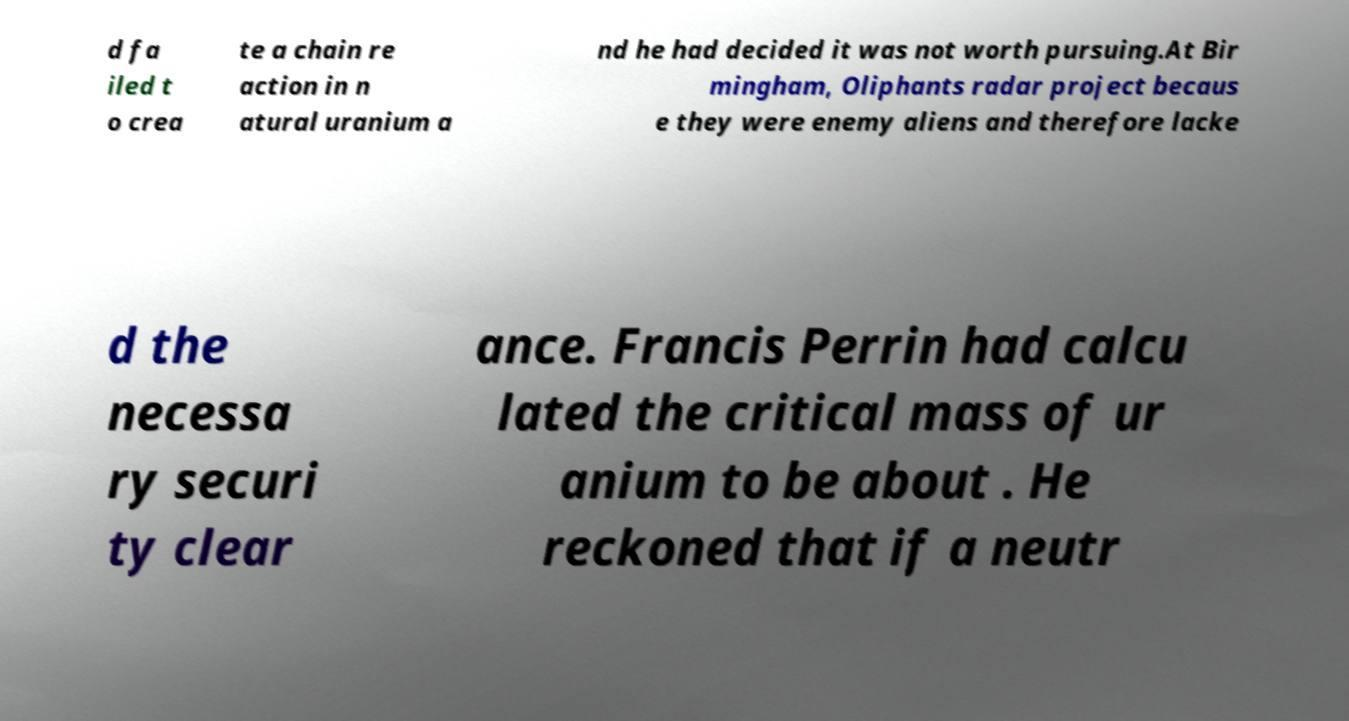Can you accurately transcribe the text from the provided image for me? d fa iled t o crea te a chain re action in n atural uranium a nd he had decided it was not worth pursuing.At Bir mingham, Oliphants radar project becaus e they were enemy aliens and therefore lacke d the necessa ry securi ty clear ance. Francis Perrin had calcu lated the critical mass of ur anium to be about . He reckoned that if a neutr 